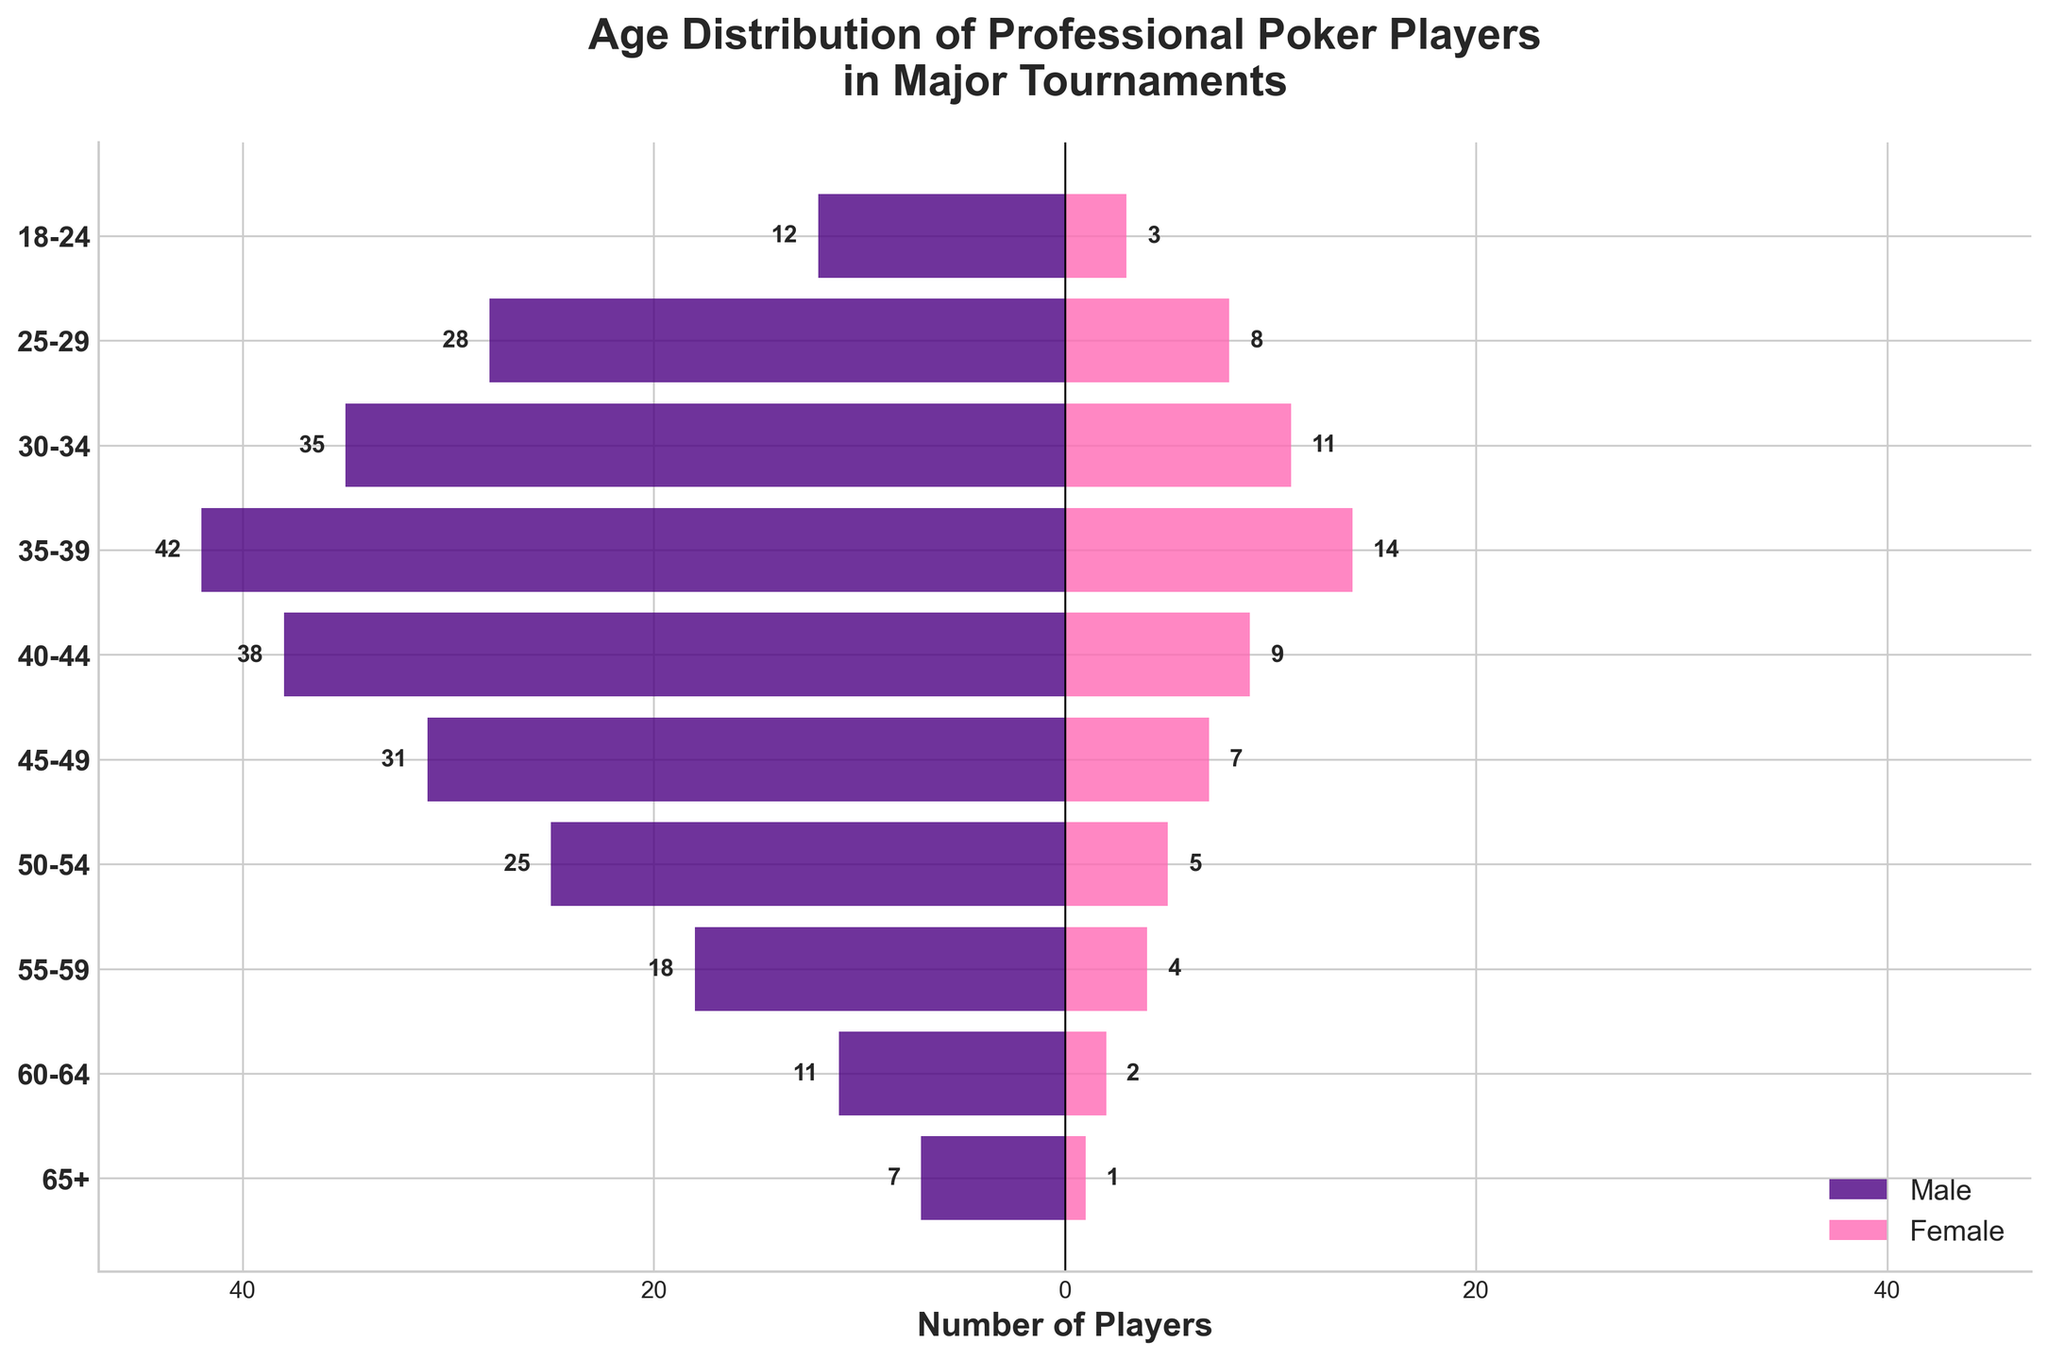How many age groups are represented in the figure? There are 10 unique age groups listed on the y-axis: 18-24, 25-29, 30-34, 35-39, 40-44, 45-49, 50-54, 55-59, 60-64, and 65+.
Answer: 10 Which age group has the highest number of male players? The 35-39 age group has the tallest bar extending to the left, representing male players.
Answer: 35-39 For the 50-54 age group, how many more males are there than females? In the 50-54 age group, there are 25 males and 5 females, so the difference is 25 - 5 = 20.
Answer: 20 What is the total number of female poker players in tournaments from the age group 30-34? The height of the bar for females in the 30-34 age group is labeled as 11, indicating there are 11 female players.
Answer: 11 Compare the number of male and female players in the 40-44 age group. Which gender has more players and by how many? There are 38 male players and 9 female players in the 40-44 age group, so males have 38 - 9 = 29 more players.
Answer: Males, by 29 What is the age group with the smallest total number of players? Summing the male and female players in each age group, the 65+ age group has the smallest total with 7 males + 1 female = 8 players.
Answer: 65+ Is there any age group where the number of female players exceeds 10? If so, specify the age group. The only age group where female players exceed 10 is 30-34 with 11 female players.
Answer: 30-34 How many total players are there in the 18-24 age group? The sum of male and female players in the 18-24 age group is 12 + 3 = 15.
Answer: 15 What's the ratio of male to female players in the 45-49 age group? The number of male players is 31, and the number of female players is 7. The ratio is 31:7.
Answer: 31:7 